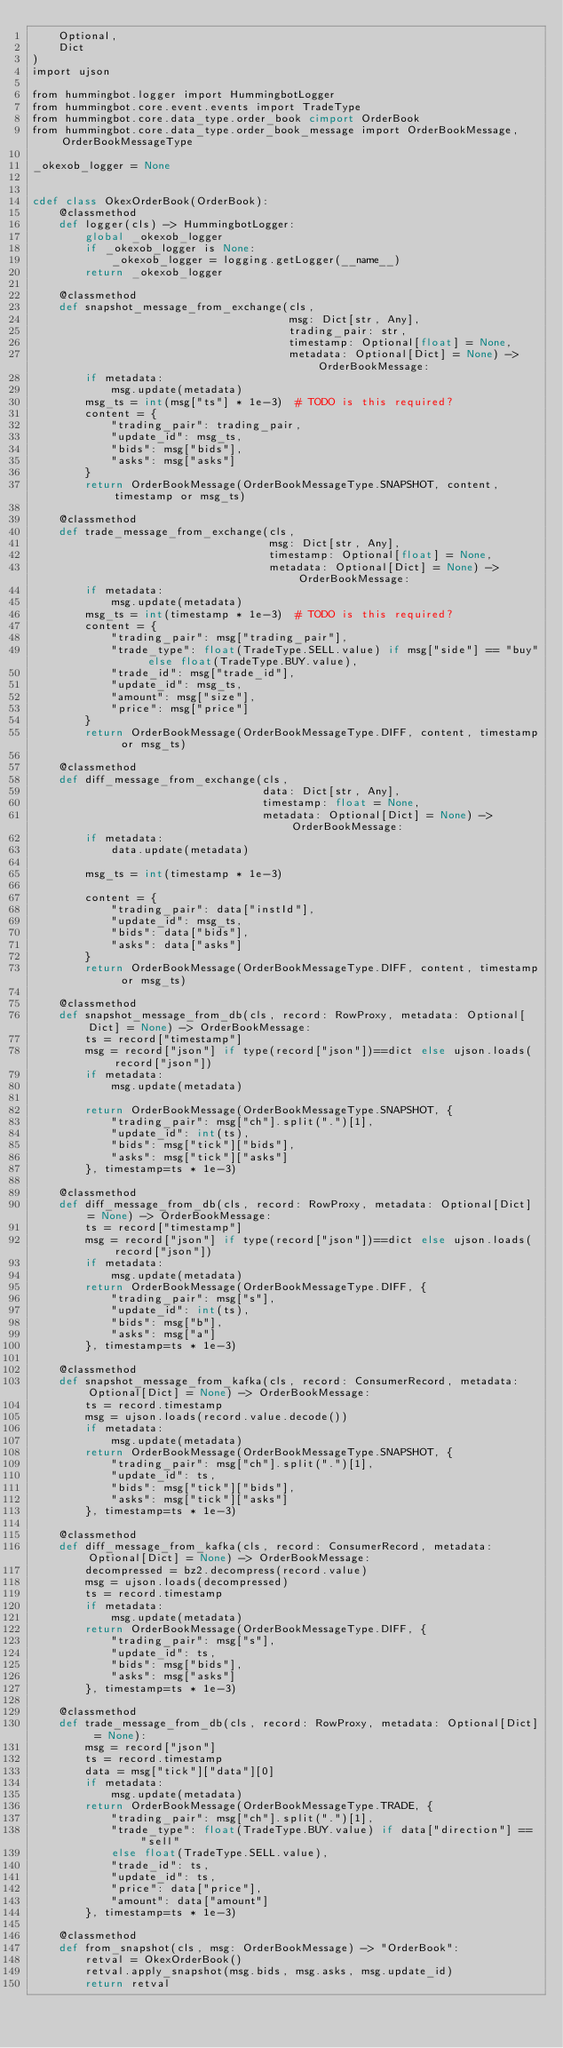Convert code to text. <code><loc_0><loc_0><loc_500><loc_500><_Cython_>    Optional,
    Dict
)
import ujson

from hummingbot.logger import HummingbotLogger
from hummingbot.core.event.events import TradeType
from hummingbot.core.data_type.order_book cimport OrderBook
from hummingbot.core.data_type.order_book_message import OrderBookMessage, OrderBookMessageType

_okexob_logger = None


cdef class OkexOrderBook(OrderBook):
    @classmethod
    def logger(cls) -> HummingbotLogger:
        global _okexob_logger
        if _okexob_logger is None:
            _okexob_logger = logging.getLogger(__name__)
        return _okexob_logger

    @classmethod
    def snapshot_message_from_exchange(cls,
                                       msg: Dict[str, Any],
                                       trading_pair: str,
                                       timestamp: Optional[float] = None,
                                       metadata: Optional[Dict] = None) -> OrderBookMessage:
        if metadata:
            msg.update(metadata)
        msg_ts = int(msg["ts"] * 1e-3)  # TODO is this required?
        content = {
            "trading_pair": trading_pair,
            "update_id": msg_ts,
            "bids": msg["bids"],
            "asks": msg["asks"]
        }
        return OrderBookMessage(OrderBookMessageType.SNAPSHOT, content, timestamp or msg_ts)

    @classmethod
    def trade_message_from_exchange(cls,
                                    msg: Dict[str, Any],
                                    timestamp: Optional[float] = None,
                                    metadata: Optional[Dict] = None) -> OrderBookMessage:
        if metadata:
            msg.update(metadata)
        msg_ts = int(timestamp * 1e-3)  # TODO is this required?
        content = {
            "trading_pair": msg["trading_pair"],
            "trade_type": float(TradeType.SELL.value) if msg["side"] == "buy" else float(TradeType.BUY.value),
            "trade_id": msg["trade_id"],
            "update_id": msg_ts,
            "amount": msg["size"],
            "price": msg["price"]
        }
        return OrderBookMessage(OrderBookMessageType.DIFF, content, timestamp or msg_ts)

    @classmethod
    def diff_message_from_exchange(cls,
                                   data: Dict[str, Any],
                                   timestamp: float = None,
                                   metadata: Optional[Dict] = None) -> OrderBookMessage:
        if metadata:
            data.update(metadata)

        msg_ts = int(timestamp * 1e-3)

        content = {
            "trading_pair": data["instId"],
            "update_id": msg_ts,
            "bids": data["bids"],
            "asks": data["asks"]
        }
        return OrderBookMessage(OrderBookMessageType.DIFF, content, timestamp or msg_ts)

    @classmethod
    def snapshot_message_from_db(cls, record: RowProxy, metadata: Optional[Dict] = None) -> OrderBookMessage:
        ts = record["timestamp"]
        msg = record["json"] if type(record["json"])==dict else ujson.loads(record["json"])
        if metadata:
            msg.update(metadata)

        return OrderBookMessage(OrderBookMessageType.SNAPSHOT, {
            "trading_pair": msg["ch"].split(".")[1],
            "update_id": int(ts),
            "bids": msg["tick"]["bids"],
            "asks": msg["tick"]["asks"]
        }, timestamp=ts * 1e-3)

    @classmethod
    def diff_message_from_db(cls, record: RowProxy, metadata: Optional[Dict] = None) -> OrderBookMessage:
        ts = record["timestamp"]
        msg = record["json"] if type(record["json"])==dict else ujson.loads(record["json"])
        if metadata:
            msg.update(metadata)
        return OrderBookMessage(OrderBookMessageType.DIFF, {
            "trading_pair": msg["s"],
            "update_id": int(ts),
            "bids": msg["b"],
            "asks": msg["a"]
        }, timestamp=ts * 1e-3)

    @classmethod
    def snapshot_message_from_kafka(cls, record: ConsumerRecord, metadata: Optional[Dict] = None) -> OrderBookMessage:
        ts = record.timestamp
        msg = ujson.loads(record.value.decode())
        if metadata:
            msg.update(metadata)
        return OrderBookMessage(OrderBookMessageType.SNAPSHOT, {
            "trading_pair": msg["ch"].split(".")[1],
            "update_id": ts,
            "bids": msg["tick"]["bids"],
            "asks": msg["tick"]["asks"]
        }, timestamp=ts * 1e-3)

    @classmethod
    def diff_message_from_kafka(cls, record: ConsumerRecord, metadata: Optional[Dict] = None) -> OrderBookMessage:
        decompressed = bz2.decompress(record.value)
        msg = ujson.loads(decompressed)
        ts = record.timestamp
        if metadata:
            msg.update(metadata)
        return OrderBookMessage(OrderBookMessageType.DIFF, {
            "trading_pair": msg["s"],
            "update_id": ts,
            "bids": msg["bids"],
            "asks": msg["asks"]
        }, timestamp=ts * 1e-3)

    @classmethod
    def trade_message_from_db(cls, record: RowProxy, metadata: Optional[Dict] = None):
        msg = record["json"]
        ts = record.timestamp
        data = msg["tick"]["data"][0]
        if metadata:
            msg.update(metadata)
        return OrderBookMessage(OrderBookMessageType.TRADE, {
            "trading_pair": msg["ch"].split(".")[1],
            "trade_type": float(TradeType.BUY.value) if data["direction"] == "sell"
            else float(TradeType.SELL.value),
            "trade_id": ts,
            "update_id": ts,
            "price": data["price"],
            "amount": data["amount"]
        }, timestamp=ts * 1e-3)

    @classmethod
    def from_snapshot(cls, msg: OrderBookMessage) -> "OrderBook":
        retval = OkexOrderBook()
        retval.apply_snapshot(msg.bids, msg.asks, msg.update_id)
        return retval
</code> 